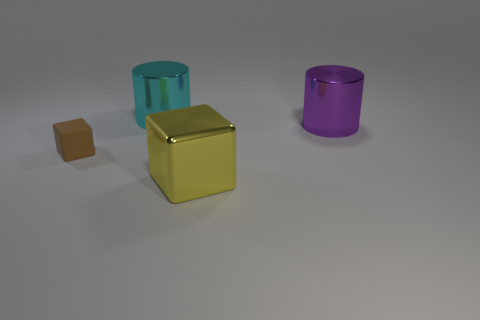Add 2 purple shiny objects. How many objects exist? 6 Subtract all yellow cubes. How many cubes are left? 1 Subtract 1 cubes. How many cubes are left? 1 Subtract 0 green balls. How many objects are left? 4 Subtract all red cylinders. Subtract all purple balls. How many cylinders are left? 2 Subtract all cyan cubes. How many cyan cylinders are left? 1 Subtract all large cyan metallic cylinders. Subtract all big yellow things. How many objects are left? 2 Add 2 small brown rubber cubes. How many small brown rubber cubes are left? 3 Add 2 cyan cylinders. How many cyan cylinders exist? 3 